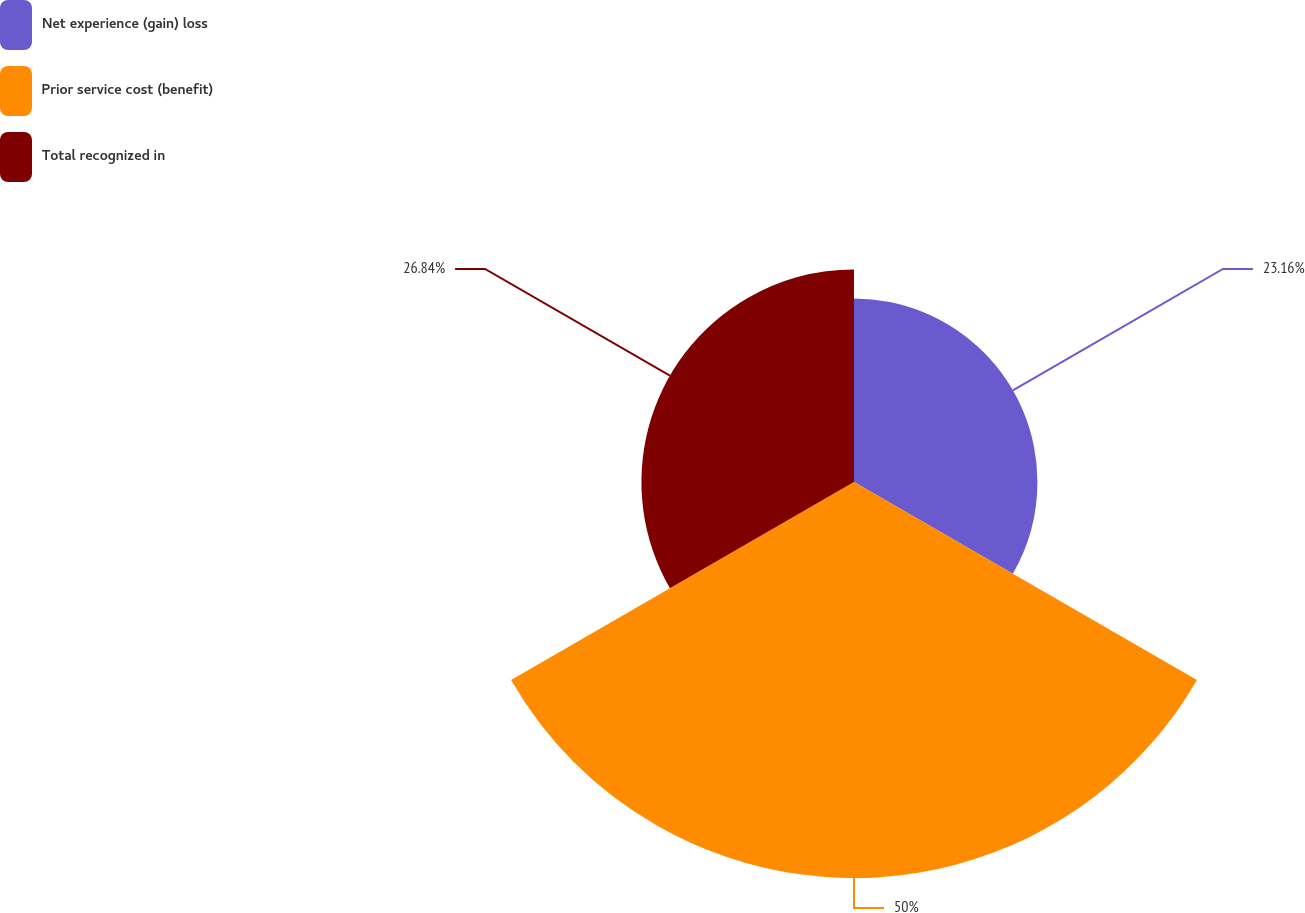Convert chart. <chart><loc_0><loc_0><loc_500><loc_500><pie_chart><fcel>Net experience (gain) loss<fcel>Prior service cost (benefit)<fcel>Total recognized in<nl><fcel>23.16%<fcel>50.0%<fcel>26.84%<nl></chart> 